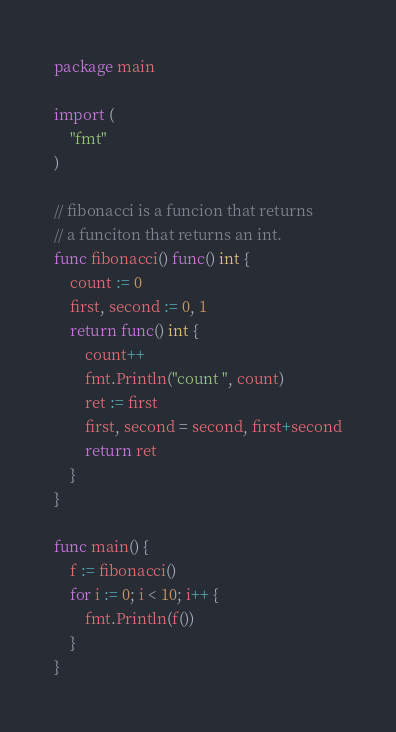<code> <loc_0><loc_0><loc_500><loc_500><_Go_>package main

import (
	"fmt"
)

// fibonacci is a funcion that returns
// a funciton that returns an int.
func fibonacci() func() int {
	count := 0
	first, second := 0, 1
	return func() int {
		count++
		fmt.Println("count ", count)
		ret := first
		first, second = second, first+second
		return ret
	}
}

func main() {
	f := fibonacci()
	for i := 0; i < 10; i++ {
		fmt.Println(f())
	}
}
</code> 